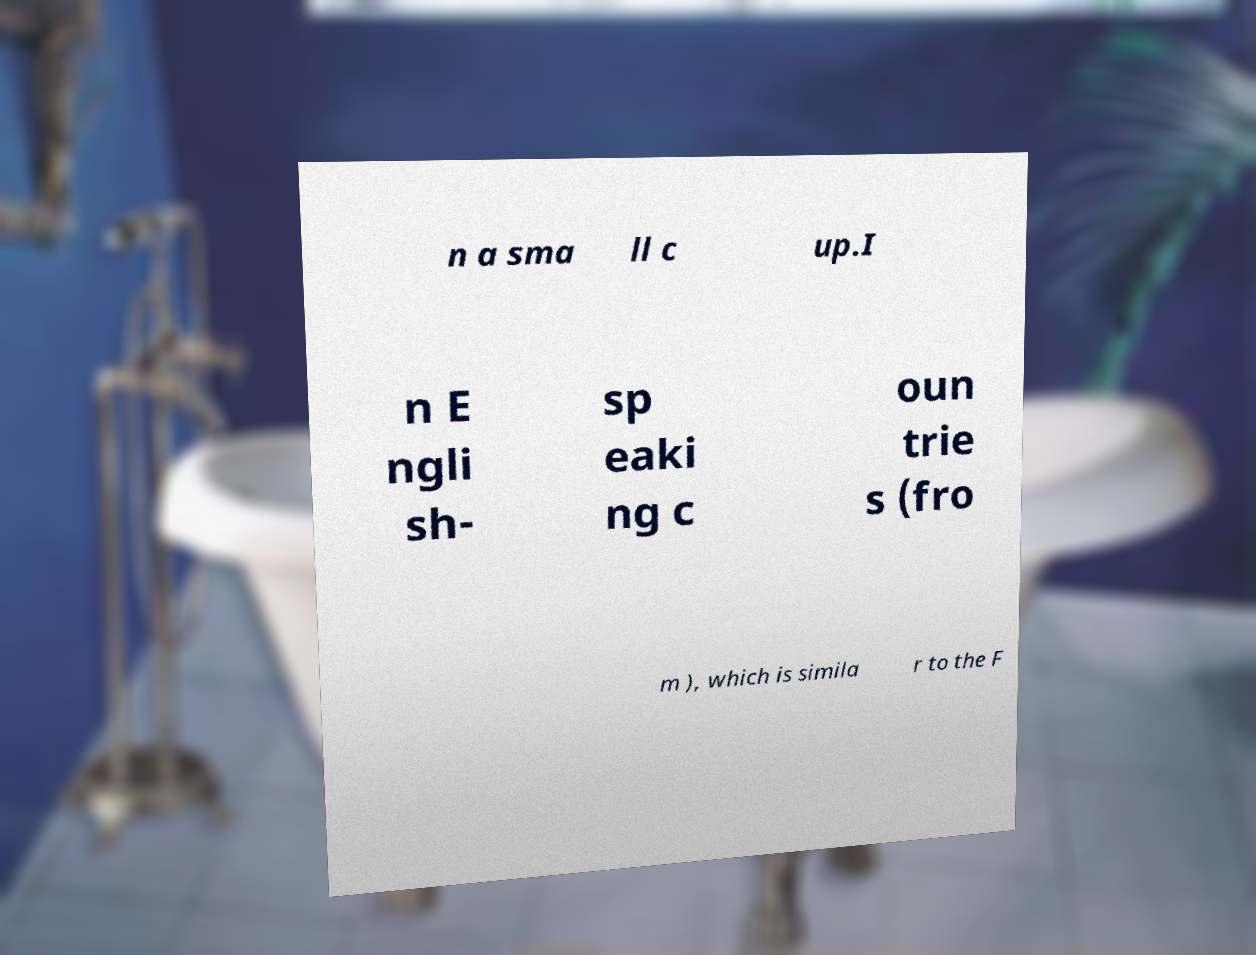Can you accurately transcribe the text from the provided image for me? n a sma ll c up.I n E ngli sh- sp eaki ng c oun trie s (fro m ), which is simila r to the F 